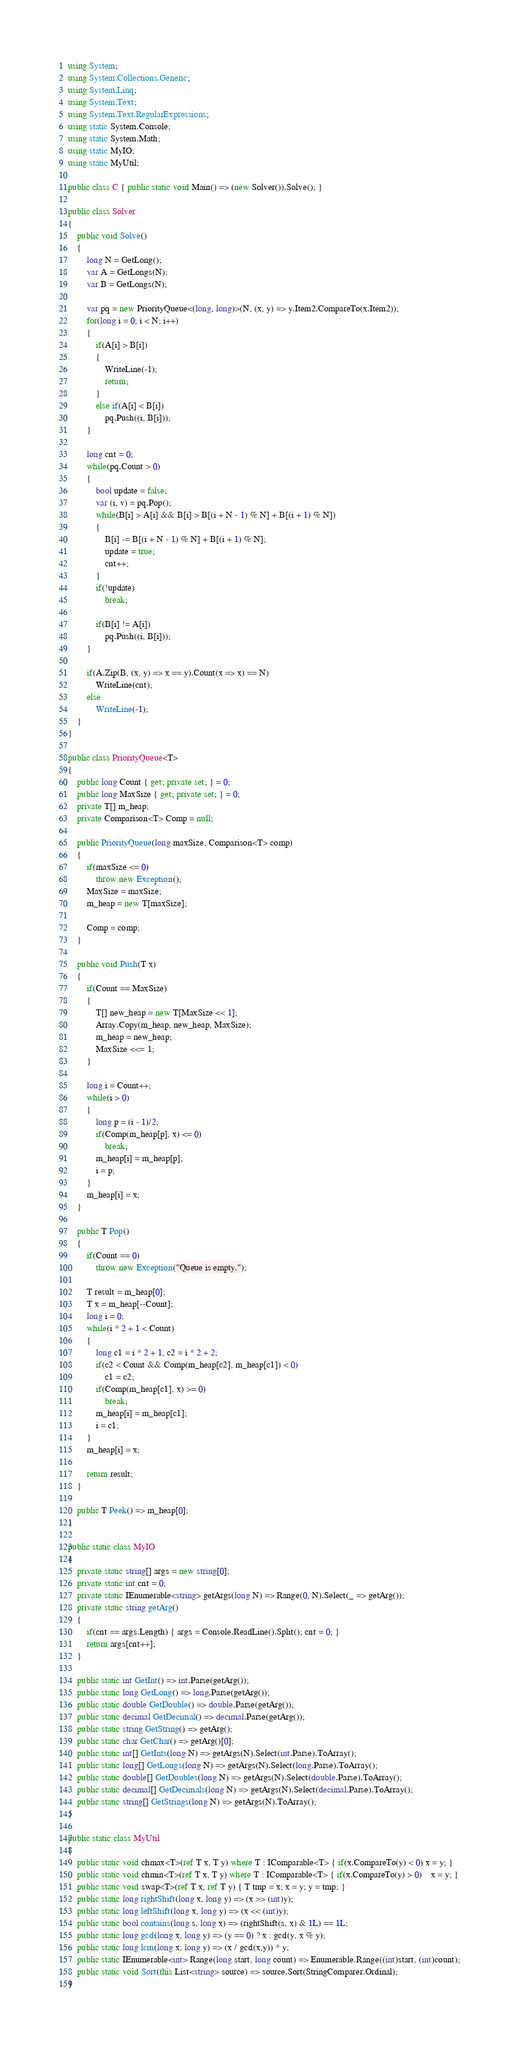Convert code to text. <code><loc_0><loc_0><loc_500><loc_500><_C#_>using System;
using System.Collections.Generic;
using System.Linq;
using System.Text;
using System.Text.RegularExpressions;
using static System.Console;
using static System.Math;
using static MyIO;
using static MyUtil;

public class C { public static void Main() => (new Solver()).Solve(); }

public class Solver
{
	public void Solve()
	{
		long N = GetLong();
		var A = GetLongs(N);
		var B = GetLongs(N);

		var pq = new PriorityQueue<(long, long)>(N, (x, y) => y.Item2.CompareTo(x.Item2));
		for(long i = 0; i < N; i++)
		{
			if(A[i] > B[i])
			{
				WriteLine(-1);
				return;
			}
			else if(A[i] < B[i])
				pq.Push((i, B[i]));
		}

		long cnt = 0;
		while(pq.Count > 0)
		{
			bool update = false;
			var (i, v) = pq.Pop();
			while(B[i] > A[i] && B[i] > B[(i + N - 1) % N] + B[(i + 1) % N])
			{
				B[i] -= B[(i + N - 1) % N] + B[(i + 1) % N];
				update = true;
				cnt++;
			}
			if(!update)
				break;

			if(B[i] != A[i])
				pq.Push((i, B[i]));
		}

		if(A.Zip(B, (x, y) => x == y).Count(x => x) == N)
			WriteLine(cnt);
		else
			WriteLine(-1);
	}
}

public class PriorityQueue<T>
{
	public long Count { get; private set; } = 0;
	public long MaxSize { get; private set; } = 0;
	private T[] m_heap;
	private Comparison<T> Comp = null;
	
	public PriorityQueue(long maxSize, Comparison<T> comp)
	{
		if(maxSize <= 0)
			throw new Exception();
		MaxSize = maxSize;
		m_heap = new T[maxSize];

		Comp = comp;
	}
	
	public void Push(T x)
	{
		if(Count == MaxSize)
		{
			T[] new_heap = new T[MaxSize << 1];
			Array.Copy(m_heap, new_heap, MaxSize);
			m_heap = new_heap;
			MaxSize <<= 1;
		}
		
		long i = Count++;
		while(i > 0)
		{
			long p = (i - 1)/2;
			if(Comp(m_heap[p], x) <= 0)
				break;
			m_heap[i] = m_heap[p];
			i = p;			
		}
		m_heap[i] = x;		
	}
	
	public T Pop()
	{
		if(Count == 0)
			throw new Exception("Queue is empty.");
		
		T result = m_heap[0];
		T x = m_heap[--Count];
		long i = 0;
		while(i * 2 + 1 < Count)
		{
			long c1 = i * 2 + 1, c2 = i * 2 + 2;
			if(c2 < Count && Comp(m_heap[c2], m_heap[c1]) < 0)
				c1 = c2;
			if(Comp(m_heap[c1], x) >= 0)
				break;
			m_heap[i] = m_heap[c1];
			i = c1;
		}
		m_heap[i] = x;
		
		return result;		
	}
	
	public T Peek() => m_heap[0];
}

public static class MyIO
{
	private static string[] args = new string[0];
	private static int cnt = 0;
	private static IEnumerable<string> getArgs(long N) => Range(0, N).Select(_ => getArg());
	private static string getArg()
	{
		if(cnt == args.Length) { args = Console.ReadLine().Split(); cnt = 0; }
		return args[cnt++];
	}

	public static int GetInt() => int.Parse(getArg());
	public static long GetLong() => long.Parse(getArg());
	public static double GetDouble() => double.Parse(getArg());
	public static decimal GetDecimal() => decimal.Parse(getArg());
	public static string GetString() => getArg();
	public static char GetChar() => getArg()[0];
	public static int[] GetInts(long N) => getArgs(N).Select(int.Parse).ToArray();
	public static long[] GetLongs(long N) => getArgs(N).Select(long.Parse).ToArray();
	public static double[] GetDoubles(long N) => getArgs(N).Select(double.Parse).ToArray();
	public static decimal[] GetDecimals(long N) => getArgs(N).Select(decimal.Parse).ToArray();
	public static string[] GetStrings(long N) => getArgs(N).ToArray();
}

public static class MyUtil
{
	public static void chmax<T>(ref T x, T y) where T : IComparable<T> { if(x.CompareTo(y) < 0) x = y; }
	public static void chmin<T>(ref T x, T y) where T : IComparable<T> { if(x.CompareTo(y) > 0)	x = y; }
	public static void swap<T>(ref T x, ref T y) { T tmp = x; x = y; y = tmp; }
	public static long rightShift(long x, long y) => (x >> (int)y);
	public static long leftShift(long x, long y) => (x << (int)y);
	public static bool contains(long s, long x) => (rightShift(s, x) & 1L) == 1L;
	public static long gcd(long x, long y) => (y == 0) ? x : gcd(y, x % y);
	public static long lcm(long x, long y) => (x / gcd(x,y)) * y;	
	public static IEnumerable<int> Range(long start, long count) => Enumerable.Range((int)start, (int)count);
	public static void Sort(this List<string> source) => source.Sort(StringComparer.Ordinal);
}
</code> 